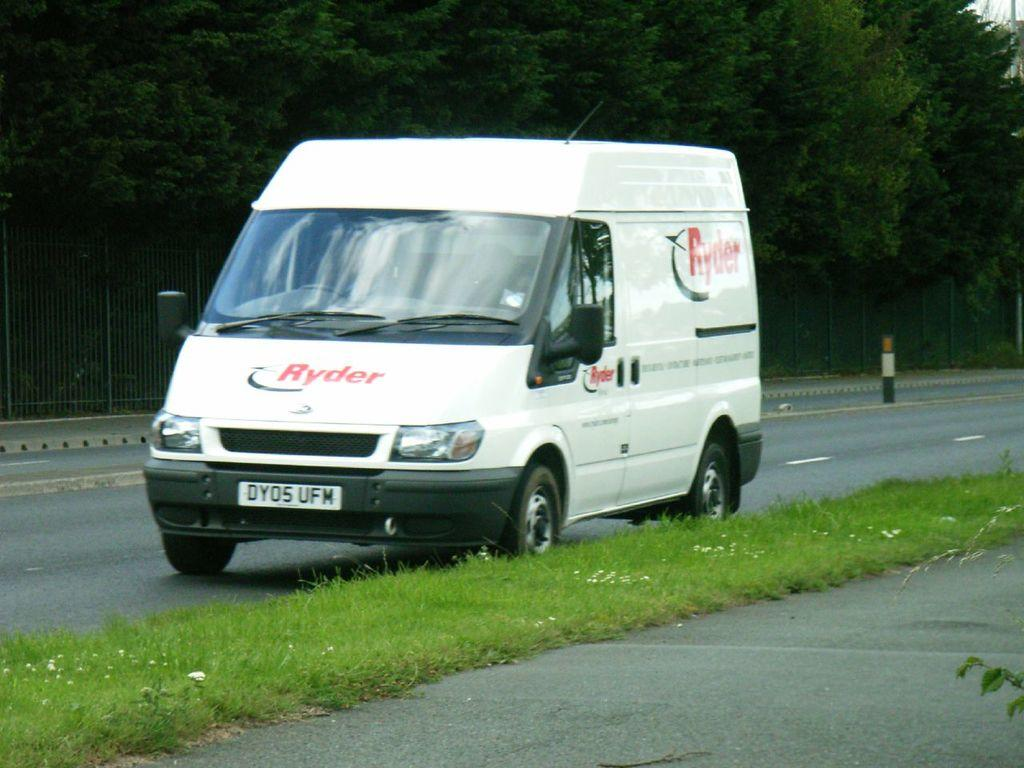What type of vehicle is in the image? There is a white vehicle in the image. Where is the vehicle located? The vehicle is on the road. What type of vegetation can be seen in the image? There is grass visible in the image. What can be seen in the background of the image? There are trees at the back in the image. Can you see a quiver of arrows in the image? There is no quiver of arrows present in the image. What type of bread is being served by the beggar in the image? There is no beggar or bread present in the image. 